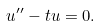Convert formula to latex. <formula><loc_0><loc_0><loc_500><loc_500>u ^ { \prime \prime } - t u = 0 .</formula> 